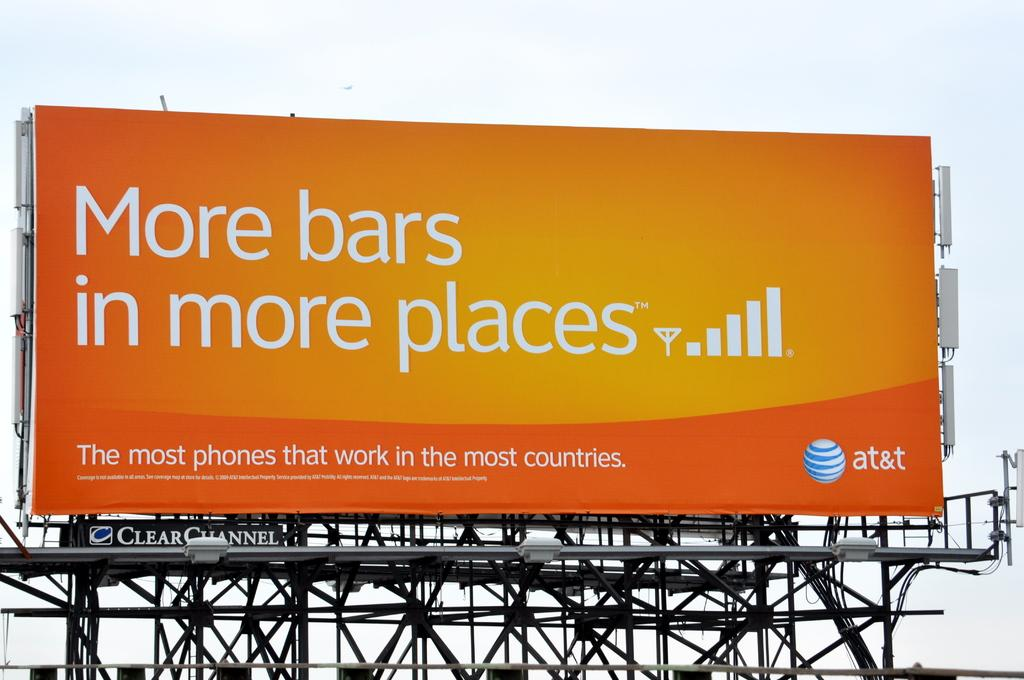<image>
Write a terse but informative summary of the picture. A billboard sign that says more bars in more places on it. 